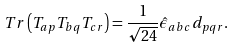Convert formula to latex. <formula><loc_0><loc_0><loc_500><loc_500>T r \left ( T _ { a p } T _ { b q } T _ { c r } \right ) = \frac { 1 } { \sqrt { 2 4 } } \hat { \epsilon } _ { a b c } d _ { p q r } .</formula> 